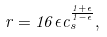<formula> <loc_0><loc_0><loc_500><loc_500>r = 1 6 \epsilon c _ { s } ^ { \frac { 1 + \epsilon } { 1 - \epsilon } } ,</formula> 